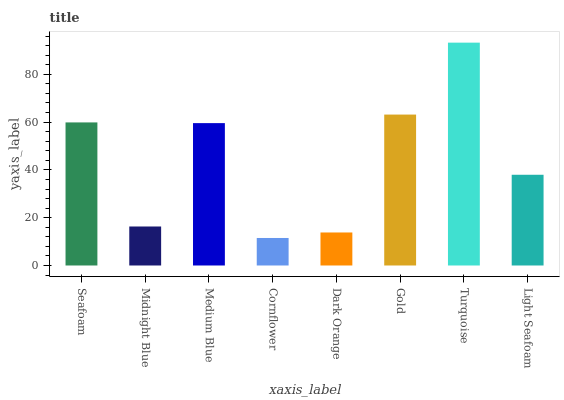Is Cornflower the minimum?
Answer yes or no. Yes. Is Turquoise the maximum?
Answer yes or no. Yes. Is Midnight Blue the minimum?
Answer yes or no. No. Is Midnight Blue the maximum?
Answer yes or no. No. Is Seafoam greater than Midnight Blue?
Answer yes or no. Yes. Is Midnight Blue less than Seafoam?
Answer yes or no. Yes. Is Midnight Blue greater than Seafoam?
Answer yes or no. No. Is Seafoam less than Midnight Blue?
Answer yes or no. No. Is Medium Blue the high median?
Answer yes or no. Yes. Is Light Seafoam the low median?
Answer yes or no. Yes. Is Seafoam the high median?
Answer yes or no. No. Is Gold the low median?
Answer yes or no. No. 